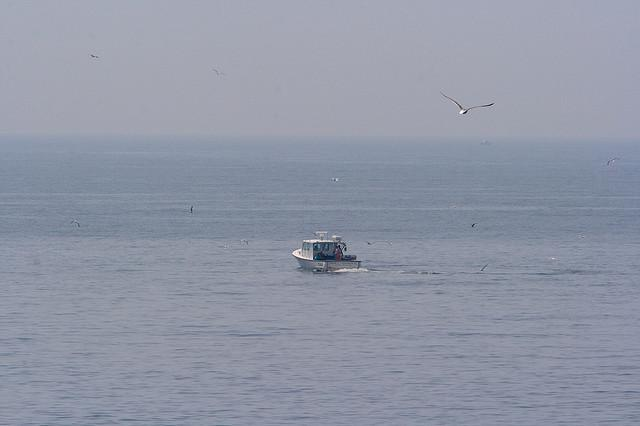What is the name of the object on top of the boat's roof? Please explain your reasoning. antenna. It's an antenna. 